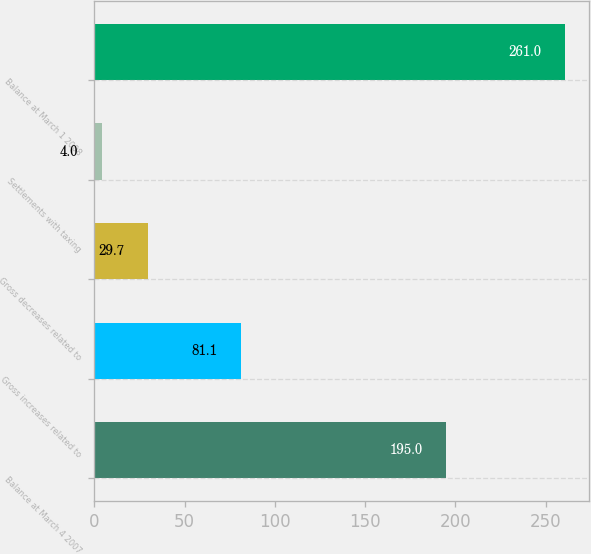Convert chart. <chart><loc_0><loc_0><loc_500><loc_500><bar_chart><fcel>Balance at March 4 2007<fcel>Gross increases related to<fcel>Gross decreases related to<fcel>Settlements with taxing<fcel>Balance at March 1 2008<nl><fcel>195<fcel>81.1<fcel>29.7<fcel>4<fcel>261<nl></chart> 